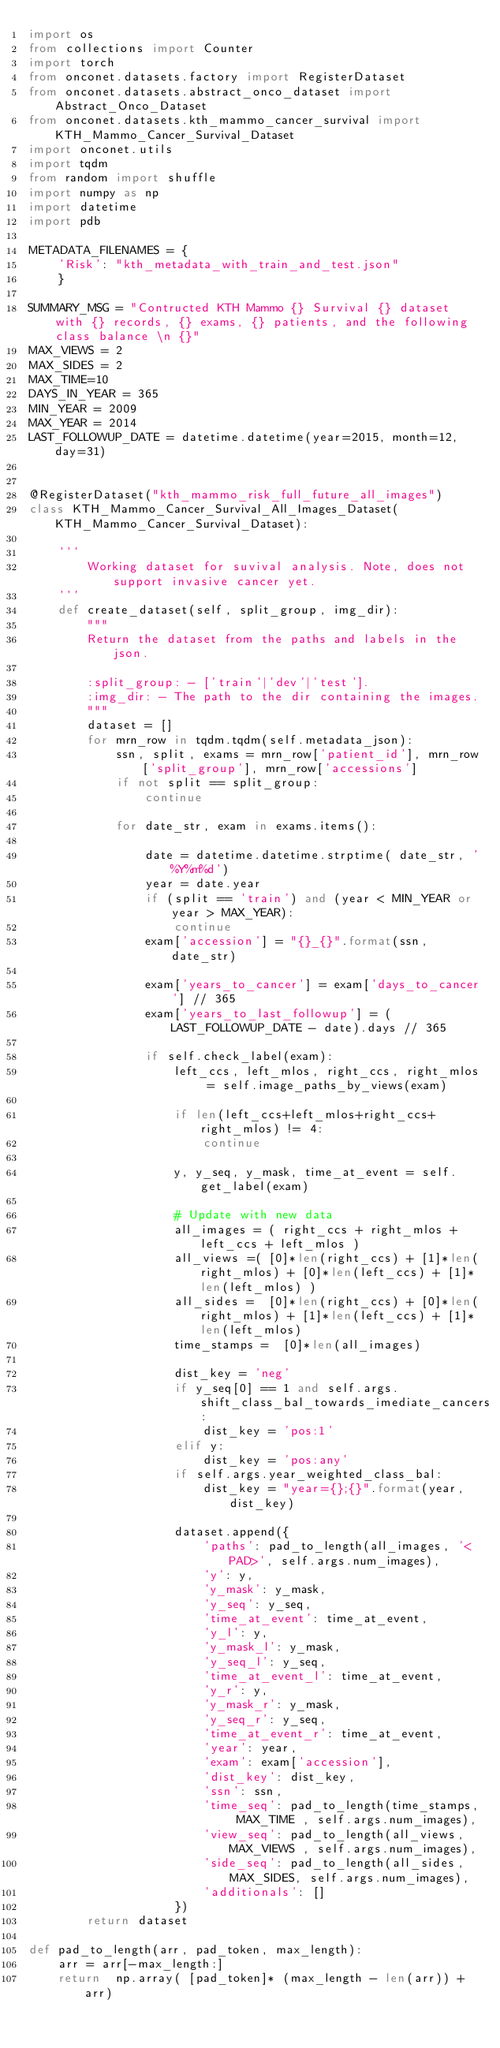Convert code to text. <code><loc_0><loc_0><loc_500><loc_500><_Python_>import os
from collections import Counter
import torch
from onconet.datasets.factory import RegisterDataset
from onconet.datasets.abstract_onco_dataset import Abstract_Onco_Dataset
from onconet.datasets.kth_mammo_cancer_survival import KTH_Mammo_Cancer_Survival_Dataset
import onconet.utils
import tqdm
from random import shuffle
import numpy as np
import datetime
import pdb

METADATA_FILENAMES = {
    'Risk': "kth_metadata_with_train_and_test.json"
    }

SUMMARY_MSG = "Contructed KTH Mammo {} Survival {} dataset with {} records, {} exams, {} patients, and the following class balance \n {}"
MAX_VIEWS = 2
MAX_SIDES = 2
MAX_TIME=10
DAYS_IN_YEAR = 365
MIN_YEAR = 2009
MAX_YEAR = 2014
LAST_FOLLOWUP_DATE = datetime.datetime(year=2015, month=12, day=31)


@RegisterDataset("kth_mammo_risk_full_future_all_images")
class KTH_Mammo_Cancer_Survival_All_Images_Dataset(KTH_Mammo_Cancer_Survival_Dataset):

    '''
        Working dataset for suvival analysis. Note, does not support invasive cancer yet.
    '''
    def create_dataset(self, split_group, img_dir):
        """
        Return the dataset from the paths and labels in the json.

        :split_group: - ['train'|'dev'|'test'].
        :img_dir: - The path to the dir containing the images.
        """
        dataset = []
        for mrn_row in tqdm.tqdm(self.metadata_json):
            ssn, split, exams = mrn_row['patient_id'], mrn_row['split_group'], mrn_row['accessions']
            if not split == split_group:
                continue

            for date_str, exam in exams.items():

                date = datetime.datetime.strptime( date_str, '%Y%m%d')
                year = date.year
                if (split == 'train') and (year < MIN_YEAR or year > MAX_YEAR):
                    continue
                exam['accession'] = "{}_{}".format(ssn, date_str)

                exam['years_to_cancer'] = exam['days_to_cancer'] // 365
                exam['years_to_last_followup'] = (LAST_FOLLOWUP_DATE - date).days // 365

                if self.check_label(exam):
                    left_ccs, left_mlos, right_ccs, right_mlos = self.image_paths_by_views(exam)

                    if len(left_ccs+left_mlos+right_ccs+right_mlos) != 4:
                        continue

                    y, y_seq, y_mask, time_at_event = self.get_label(exam)

                    # Update with new data
                    all_images = ( right_ccs + right_mlos + left_ccs + left_mlos )
                    all_views =( [0]*len(right_ccs) + [1]*len(right_mlos) + [0]*len(left_ccs) + [1]*len(left_mlos) )
                    all_sides =  [0]*len(right_ccs) + [0]*len(right_mlos) + [1]*len(left_ccs) + [1]*len(left_mlos)
                    time_stamps =  [0]*len(all_images)

                    dist_key = 'neg'
                    if y_seq[0] == 1 and self.args.shift_class_bal_towards_imediate_cancers:
                        dist_key = 'pos:1'
                    elif y:
                        dist_key = 'pos:any'
                    if self.args.year_weighted_class_bal:
                        dist_key = "year={};{}".format(year, dist_key)

                    dataset.append({
                        'paths': pad_to_length(all_images, '<PAD>', self.args.num_images),
                        'y': y,
                        'y_mask': y_mask,
                        'y_seq': y_seq,
                        'time_at_event': time_at_event,
                        'y_l': y,
                        'y_mask_l': y_mask,
                        'y_seq_l': y_seq,
                        'time_at_event_l': time_at_event,
                        'y_r': y,
                        'y_mask_r': y_mask,
                        'y_seq_r': y_seq,
                        'time_at_event_r': time_at_event,
                        'year': year,
                        'exam': exam['accession'],
                        'dist_key': dist_key,
                        'ssn': ssn,
                        'time_seq': pad_to_length(time_stamps, MAX_TIME , self.args.num_images),
                        'view_seq': pad_to_length(all_views, MAX_VIEWS , self.args.num_images),
                        'side_seq': pad_to_length(all_sides, MAX_SIDES, self.args.num_images),
                        'additionals': []
                    })
        return dataset

def pad_to_length(arr, pad_token, max_length):
    arr = arr[-max_length:]
    return  np.array( [pad_token]* (max_length - len(arr)) + arr)


</code> 